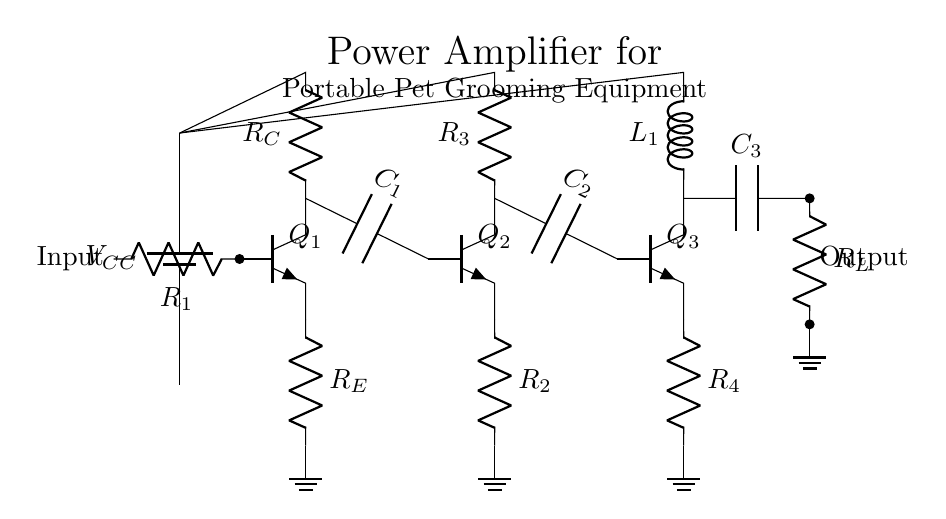What is the role of Q1 in this circuit? Q1 serves as the input transistor in the amplifier configuration, where it amplifies the input signal received at its base terminal.
Answer: input transistor What components are connected to the emitter of Q3? The emitter of Q3 is connected to a resistor labeled R4, which pulls current to ground, providing stability and setting biasing conditions for the transistor.
Answer: R4 How many capacitors are present in the circuit? Upon examination, the circuit contains three capacitors: C1, C2, and C3, which are used for AC coupling and stabilization within the amplifier stages.
Answer: three What is the main purpose of this power amplifier? The main purpose of this power amplifier is to amplify low-level signals from the portable pet grooming equipment to drive a load effectively, providing sufficient power for operation.
Answer: amplify signals What type of circuit is this? This circuit is classified as a power amplifier because it is designed to increase the power level of an input signal to drive an output load with greater current capability.
Answer: power amplifier Which component provides the power supply in the circuit? The power supply is provided by the battery, indicated as VCC, which delivers the necessary voltage for the operation of the transistors.
Answer: battery 